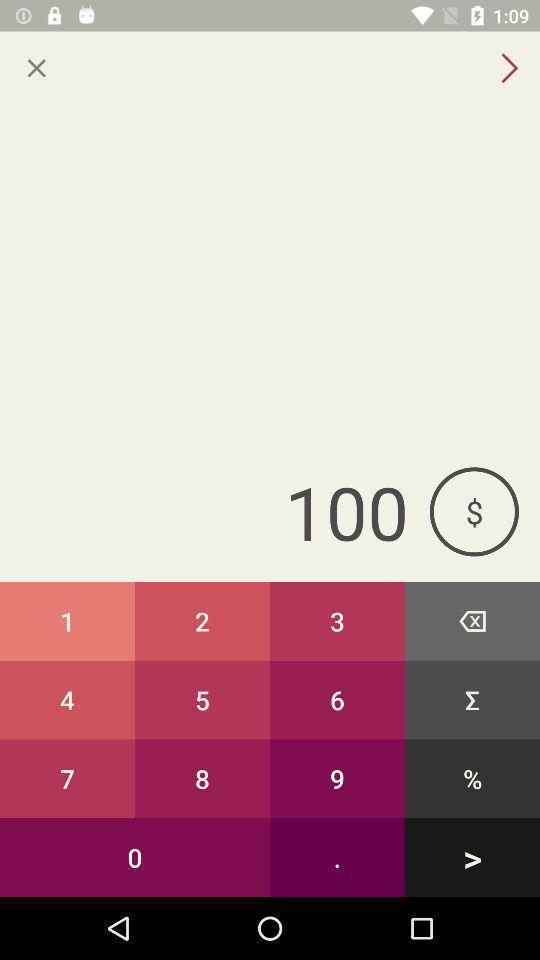Tell me about the visual elements in this screen capture. Display showing calculation page. 